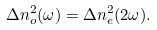<formula> <loc_0><loc_0><loc_500><loc_500>\Delta n _ { o } ^ { 2 } ( \omega ) = \Delta n _ { e } ^ { 2 } ( 2 \omega ) .</formula> 